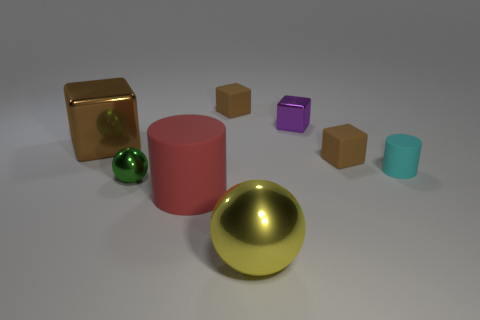How many brown blocks must be subtracted to get 1 brown blocks? 2 Add 1 tiny metal cylinders. How many objects exist? 9 Subtract all small cubes. How many cubes are left? 1 Subtract 1 cylinders. How many cylinders are left? 1 Subtract all green balls. Subtract all blue cylinders. How many balls are left? 1 Subtract all purple cylinders. How many brown cubes are left? 3 Subtract all tiny purple rubber balls. Subtract all large brown objects. How many objects are left? 7 Add 7 tiny matte blocks. How many tiny matte blocks are left? 9 Add 7 small yellow rubber objects. How many small yellow rubber objects exist? 7 Subtract all cyan cylinders. How many cylinders are left? 1 